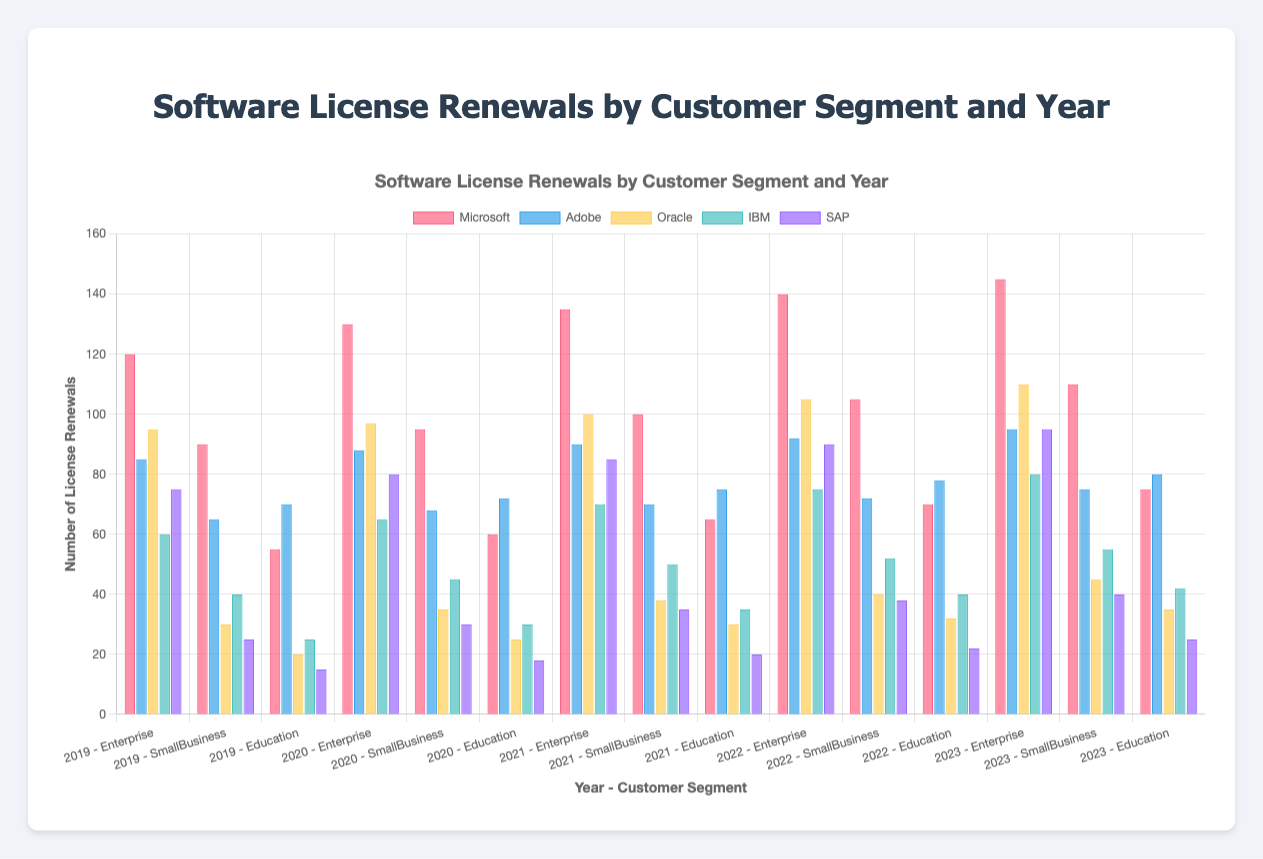Which vendor had the highest number of license renewals in the Enterprise segment in 2023? From the chart, identify the highest bar for the Enterprise segment in 2023 and find the corresponding vendor's label.
Answer: Microsoft How many more licenses did Microsoft have compared to Oracle in the Education segment in 2023? Locate the bars for Microsoft and Oracle in the Education segment for 2023, then subtract Oracle's value from Microsoft's value. Microsoft has 75 renewals and Oracle has 35, so 75 - 35 = 40.
Answer: 40 What is the average number of license renewals for SAP across all segments in 2020? Sum the number of renewals for SAP across all segments in 2020 and then divide by the number of segments. For 2020: Enterprise (80), SmallBusiness (30), Education (18). The sum is 80 + 30 + 18 = 128, and the average is 128 / 3 ≈ 42.67.
Answer: 42.67 Which year showed the greatest increase in Adobe's license renewals in the SmallBusiness segment? Compare the bars for Adobe in the SmallBusiness segment year by year and identify the year with the greatest positive difference. From 2019 (65) to 2020 (68) increased by 3, from 2020 to 2021 (70) increased by 2, from 2021 to 2022 (72) increased by 2, from 2022 to 2023 (75) increased by 3. So, 2019 to 2020 and 2022 to 2023 both show the greatest increase which is 3.
Answer: 2019 to 2020 and 2022 to 2023 Which customer segment had the least number of license renewals for IBM in 2022? Look at the IBM bars for 2022 across all segments and identify the shortest bar. For 2022, the IBM renewals are: Enterprise (75), SmallBusiness (52), Education (40). The least is in Education, which is 40.
Answer: Education What is the percentage increase of Oracle's license renewals in the Enterprise segment from 2019 to 2023? Calculate the percentage increase using the formula: ((new value - old value) / old value) * 100. For Oracle in the Enterprise segment, from 2019 (95) to 2023 (110), the increase is (110 - 95) / 95 * 100 ≈ 15.79%.
Answer: 15.79% In which year did Microsoft have the highest total number of renewals across all segments? Sum the renewals for Microsoft across all segments for each year and compare. The totals are: 2019 (265), 2020 (285), 2021 (300), 2022 (315), 2023 (330). 2023 has the highest total with 330 renewals.
Answer: 2023 How did the number of Oracle renewals in the SmallBusiness segment change from 2020 to 2022? Observe the height of the bars for Oracle in the SmallBusiness segment for 2020 and 2022. In 2020, Oracle had 35 renewals; in 2022, Oracle had 40 renewals. The change is 40 - 35 = 5.
Answer: Increased by 5 What is the average number of renewals for all vendors in the Education segment in 2021? Sum the number of renewals for each vendor in the Education segment in 2021, then divide by the number of vendors. The sum is Microsoft (65), Adobe (75), Oracle (30), IBM (35), SAP (20). The total is 65 + 75 + 30 + 35 + 20 = 225, and the average is 225 / 5 = 45.
Answer: 45 Which color represents SAP in the chart? Examine the legend in the chart to see which color corresponds to SAP.
Answer: Purple 